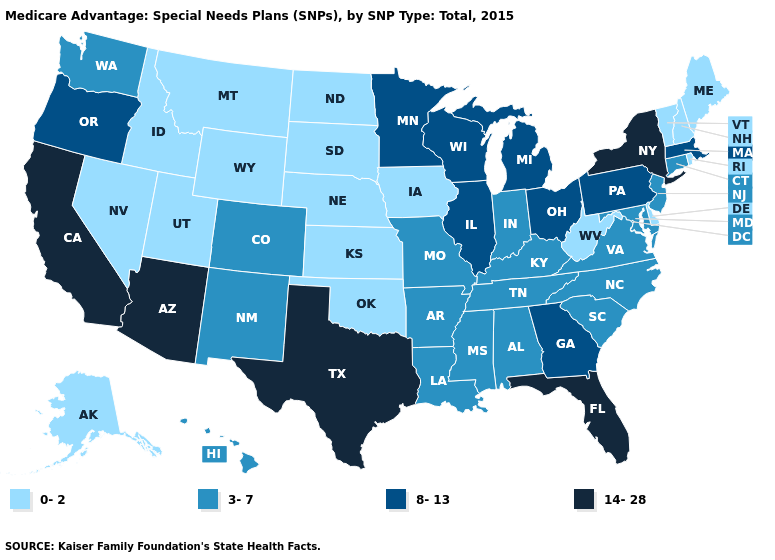Does California have a higher value than Texas?
Answer briefly. No. What is the value of Washington?
Quick response, please. 3-7. What is the value of Illinois?
Be succinct. 8-13. What is the value of Oregon?
Keep it brief. 8-13. Does the map have missing data?
Give a very brief answer. No. Which states have the lowest value in the USA?
Write a very short answer. Alaska, Delaware, Iowa, Idaho, Kansas, Maine, Montana, North Dakota, Nebraska, New Hampshire, Nevada, Oklahoma, Rhode Island, South Dakota, Utah, Vermont, West Virginia, Wyoming. Does the first symbol in the legend represent the smallest category?
Give a very brief answer. Yes. What is the lowest value in the South?
Short answer required. 0-2. Name the states that have a value in the range 14-28?
Be succinct. Arizona, California, Florida, New York, Texas. Name the states that have a value in the range 3-7?
Be succinct. Alabama, Arkansas, Colorado, Connecticut, Hawaii, Indiana, Kentucky, Louisiana, Maryland, Missouri, Mississippi, North Carolina, New Jersey, New Mexico, South Carolina, Tennessee, Virginia, Washington. What is the value of Tennessee?
Be succinct. 3-7. What is the value of Idaho?
Give a very brief answer. 0-2. Name the states that have a value in the range 8-13?
Give a very brief answer. Georgia, Illinois, Massachusetts, Michigan, Minnesota, Ohio, Oregon, Pennsylvania, Wisconsin. What is the value of Alaska?
Short answer required. 0-2. Does Utah have the lowest value in the West?
Write a very short answer. Yes. 